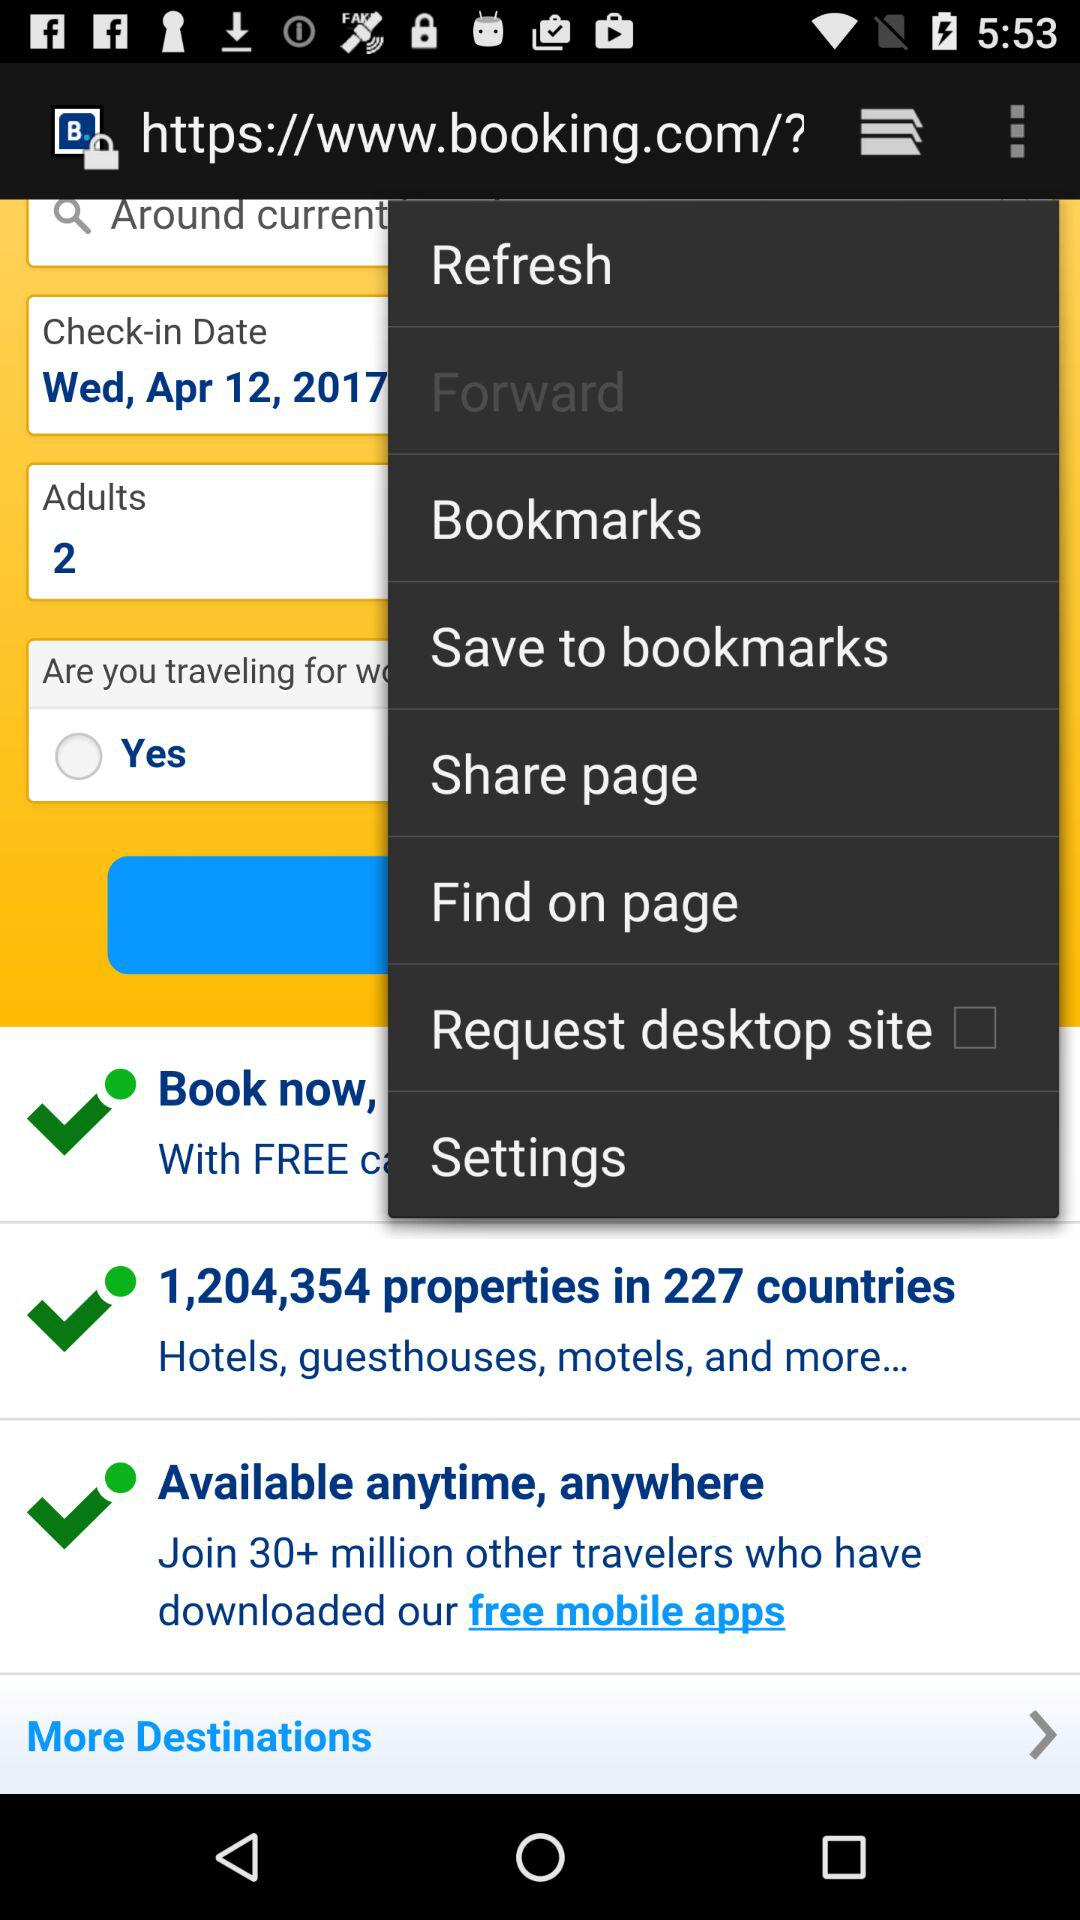How many properties are there? There are 1,204,354 properties. 